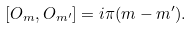Convert formula to latex. <formula><loc_0><loc_0><loc_500><loc_500>[ O _ { m } , O _ { m ^ { \prime } } ] = i \pi ( m - m ^ { \prime } ) .</formula> 